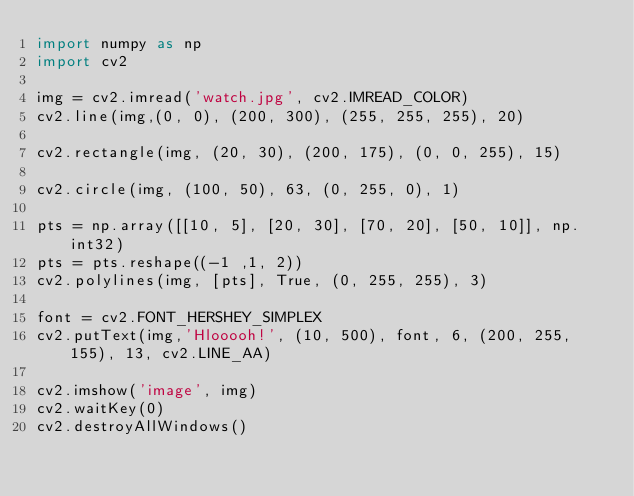<code> <loc_0><loc_0><loc_500><loc_500><_Python_>import numpy as np
import cv2

img = cv2.imread('watch.jpg', cv2.IMREAD_COLOR)
cv2.line(img,(0, 0), (200, 300), (255, 255, 255), 20)

cv2.rectangle(img, (20, 30), (200, 175), (0, 0, 255), 15)

cv2.circle(img, (100, 50), 63, (0, 255, 0), 1)

pts = np.array([[10, 5], [20, 30], [70, 20], [50, 10]], np.int32)
pts = pts.reshape((-1 ,1, 2))
cv2.polylines(img, [pts], True, (0, 255, 255), 3)

font = cv2.FONT_HERSHEY_SIMPLEX
cv2.putText(img,'Hlooooh!', (10, 500), font, 6, (200, 255, 155), 13, cv2.LINE_AA)

cv2.imshow('image', img)
cv2.waitKey(0)
cv2.destroyAllWindows()
</code> 